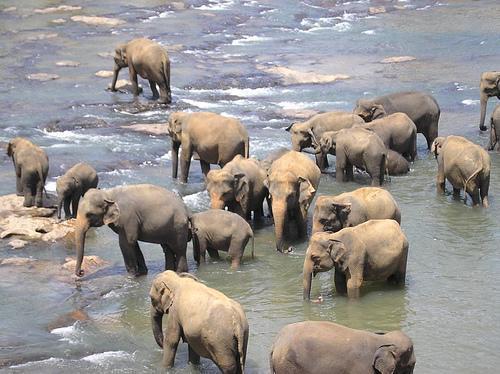How many elephants are visible?
Give a very brief answer. 11. 